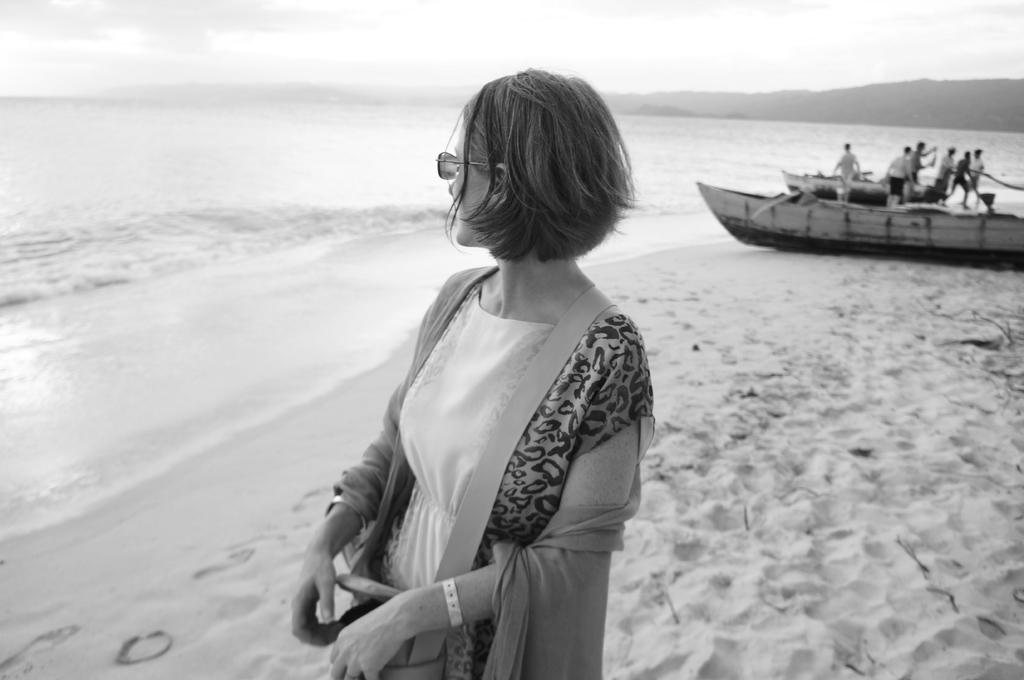Who is the main subject in the foreground of the image? There is a woman in the foreground of the image. What can be seen at the top of the image? The sky is visible at the top of the image. What geographical feature is in the middle of the image? There is a hill and sea in the middle of the image. What type of vehicle is on the right side of the image? There is a boat on the right side of the image. Are there any people on the boat? Yes, there are people on the boat. What type of crack can be seen on the boat in the image? There is no crack visible on the boat in the image. 